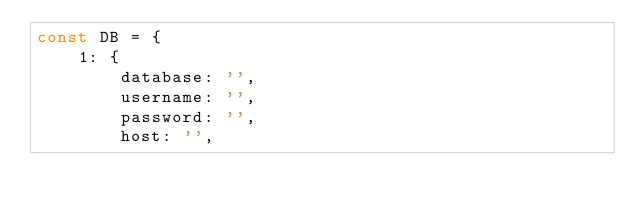Convert code to text. <code><loc_0><loc_0><loc_500><loc_500><_JavaScript_>const DB = {
    1: {
        database: '',
        username: '',
        password: '',
        host: '',</code> 